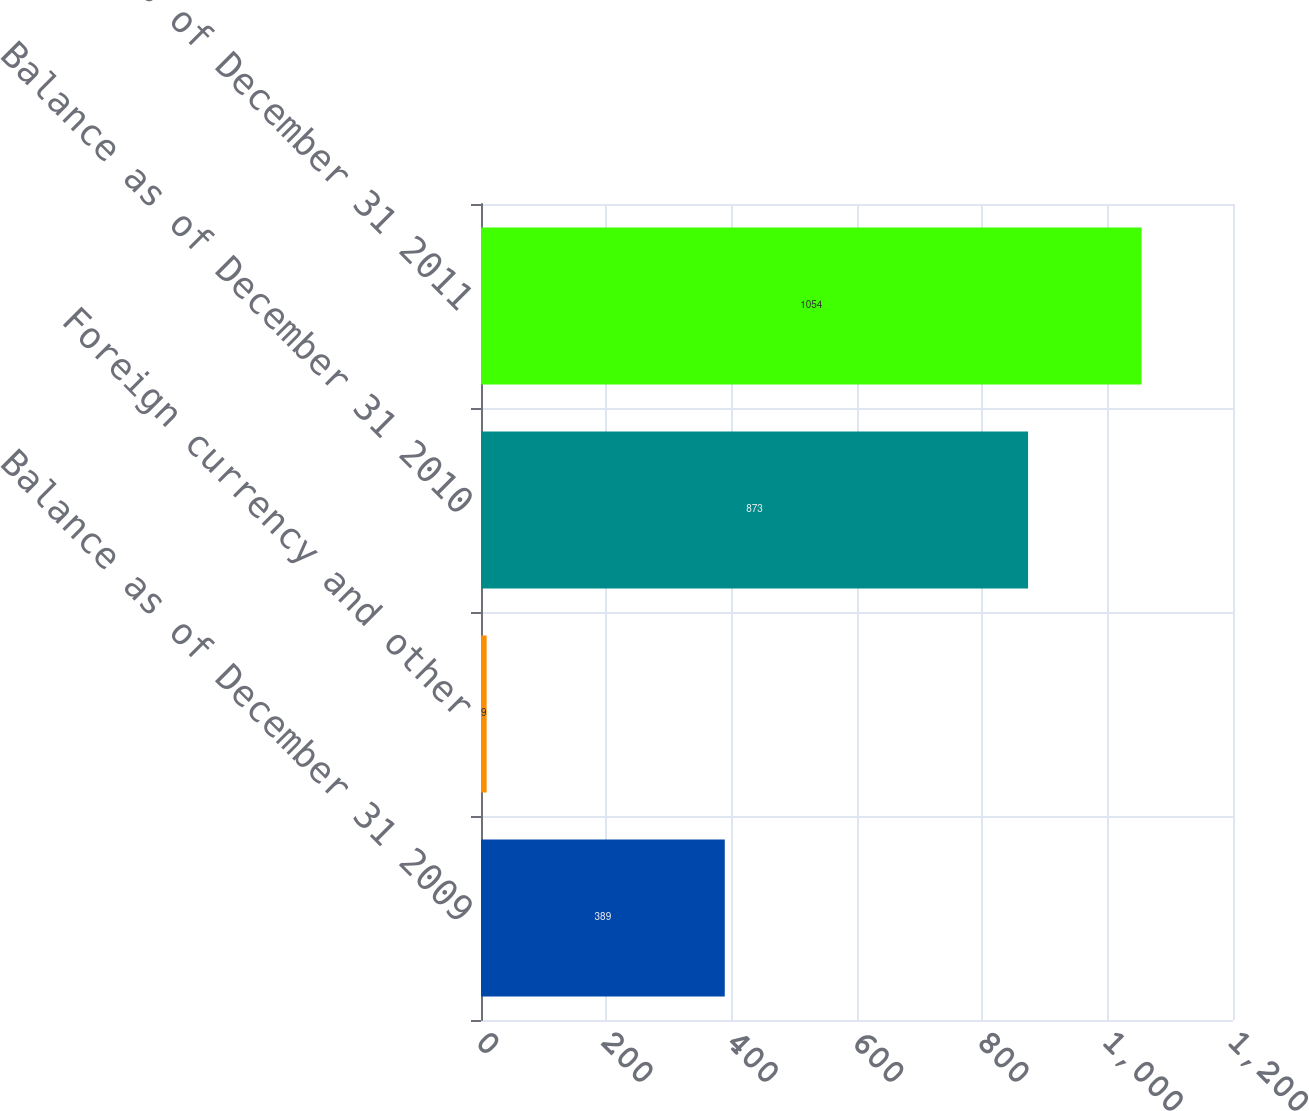Convert chart to OTSL. <chart><loc_0><loc_0><loc_500><loc_500><bar_chart><fcel>Balance as of December 31 2009<fcel>Foreign currency and other<fcel>Balance as of December 31 2010<fcel>Balance as of December 31 2011<nl><fcel>389<fcel>9<fcel>873<fcel>1054<nl></chart> 